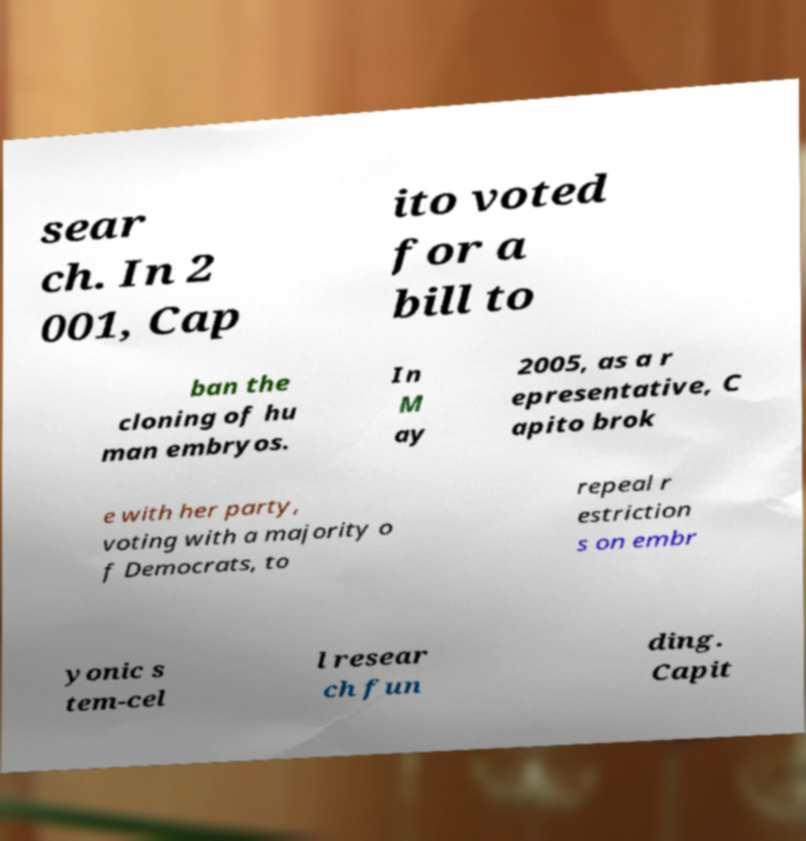I need the written content from this picture converted into text. Can you do that? sear ch. In 2 001, Cap ito voted for a bill to ban the cloning of hu man embryos. In M ay 2005, as a r epresentative, C apito brok e with her party, voting with a majority o f Democrats, to repeal r estriction s on embr yonic s tem-cel l resear ch fun ding. Capit 